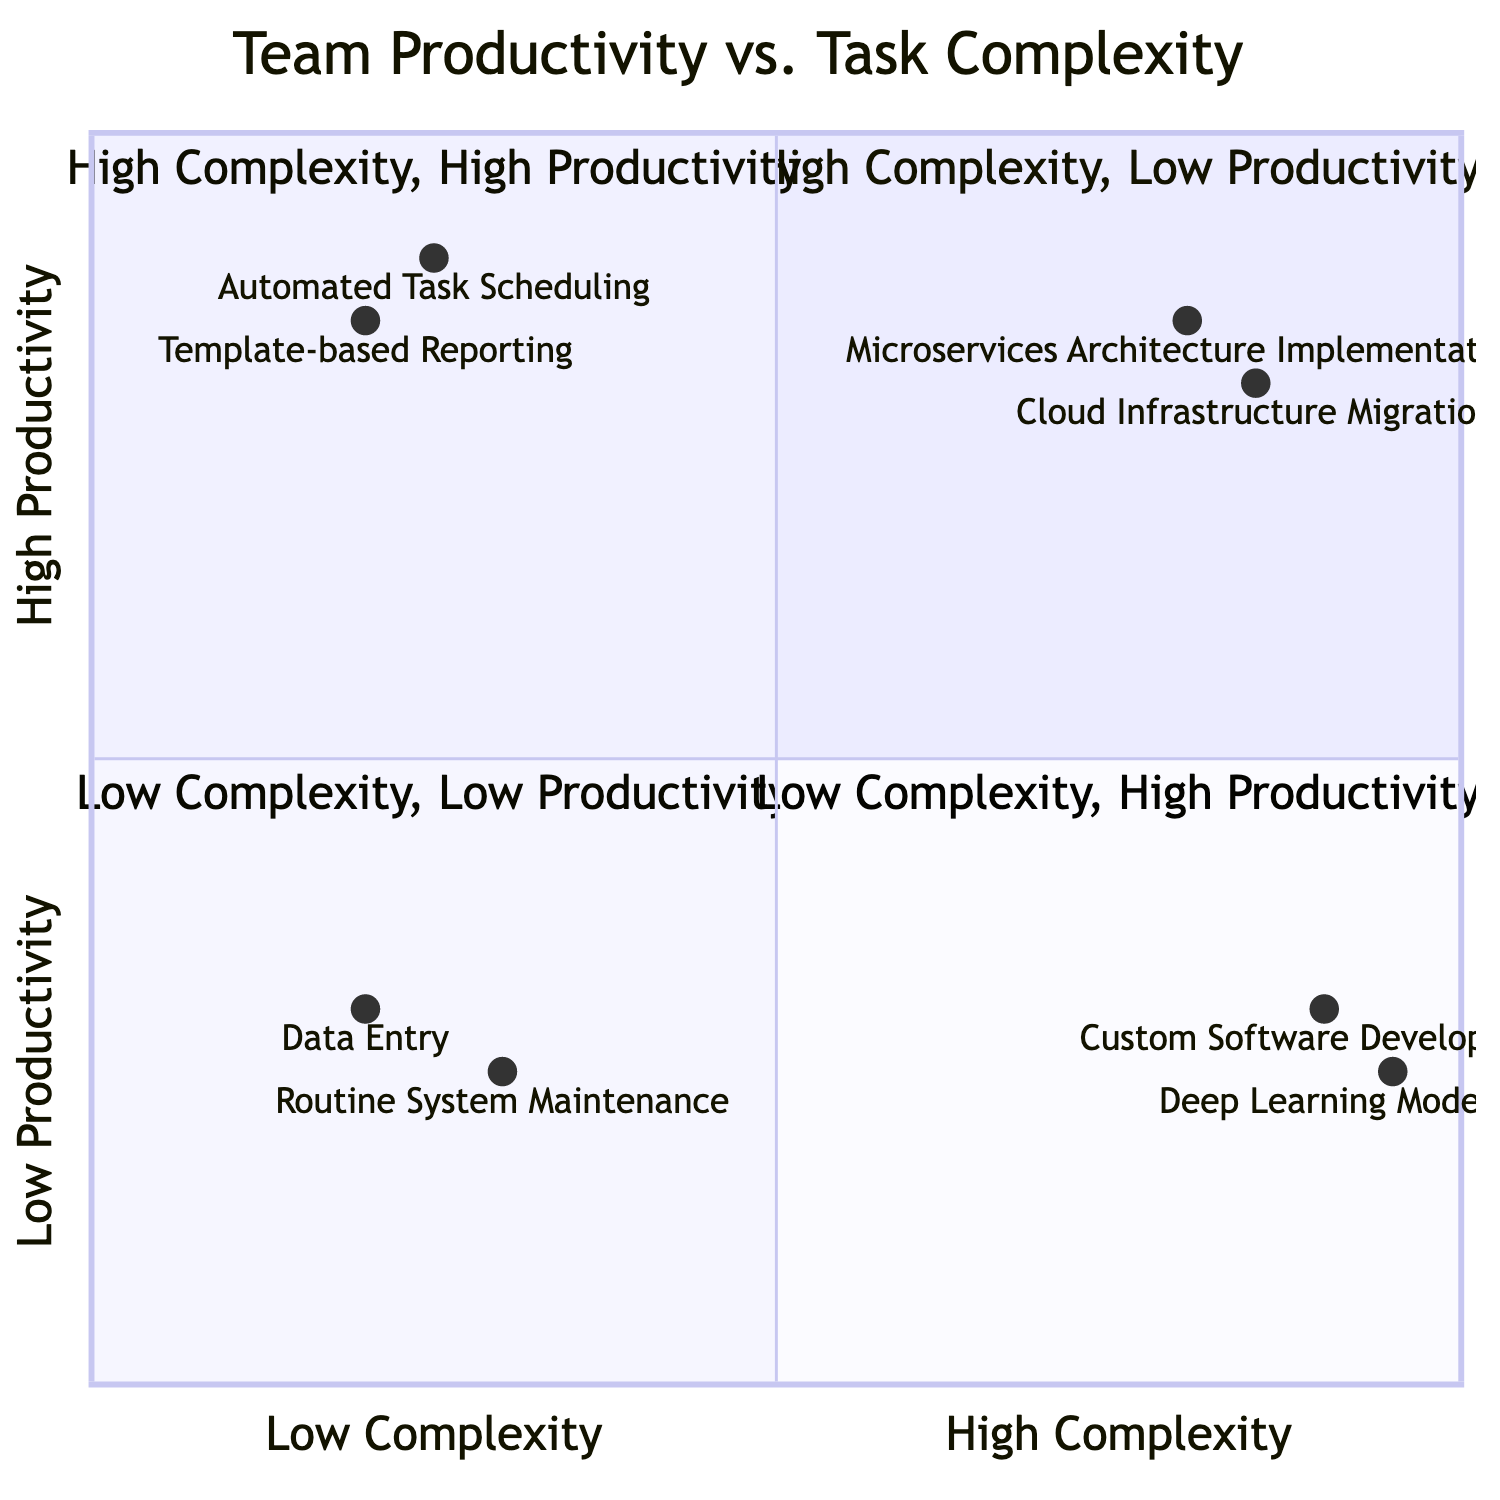What is the task type located in the "High Complexity, Low Productivity" quadrant? In the "High Complexity, Low Productivity" quadrant, the examples listed are "Custom Software Development" and "Deep Learning Model Training." The question seeks one task type from this quadrant.
Answer: Custom Software Development How many task types are in the "Low Complexity, High Productivity" quadrant? The "Low Complexity, High Productivity" quadrant contains two examples: "Automated Task Scheduling" and "Template-based Reporting." So, the count of task types is two.
Answer: 2 Which task type has the highest team productivity? Observing the quadrants, "Microservices Architecture Implementation" and "Automated Task Scheduling" are both found in higher productivity quadrants, but "Microservices Architecture Implementation" has a productivity value of 0.85, which is the highest among all listed task types.
Answer: Microservices Architecture Implementation What is the productivity value of "Cloud Infrastructure Migration"? The "Cloud Infrastructure Migration" task type is positioned in the "High Complexity, High Productivity" quadrant, with a specific productivity value of 0.8 attached to it.
Answer: 0.8 Are there any task types in the "Low Complexity, Low Productivity" quadrant? Indeed, the "Low Complexity, Low Productivity" quadrant comprises two task types: "Data Entry" and "Routine System Maintenance," confirming that there are task types present in this quadrant.
Answer: Yes Which task type has the lowest productivity value? Within the quadrants, the task type "Routine System Maintenance" demonstrates the lowest productivity value of 0.25, making it the least productive task type according to the diagram.
Answer: Routine System Maintenance What does the "High Complexity, High Productivity" quadrant imply about task efficiency? This quadrant suggests that tasks here are complex yet yield high productivity levels. Specifically, the "Microservices Architecture Implementation" and "Cloud Infrastructure Migration" are examples that indicate effective handling of complex tasks resulting in high output.
Answer: High efficiency What are the task types classified under "Low Complexity, Low Productivity"? The two task types in the "Low Complexity, Low Productivity" quadrant are "Data Entry" and "Routine System Maintenance." This classification indicates typical tasks that are simple but not highly productive.
Answer: Data Entry, Routine System Maintenance 